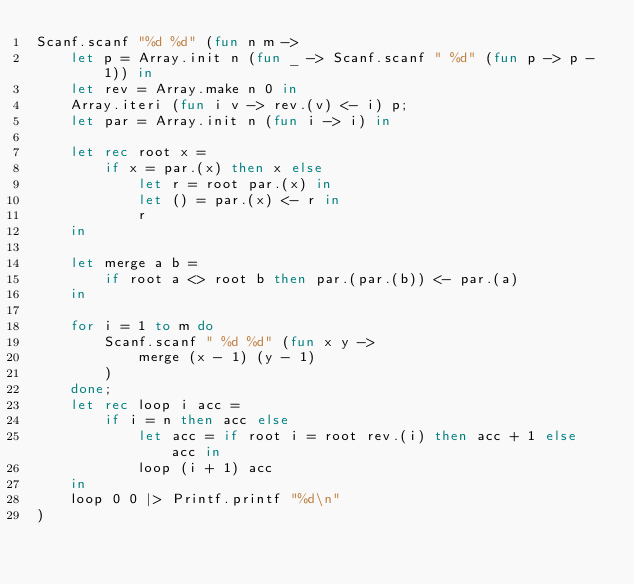Convert code to text. <code><loc_0><loc_0><loc_500><loc_500><_OCaml_>Scanf.scanf "%d %d" (fun n m ->
    let p = Array.init n (fun _ -> Scanf.scanf " %d" (fun p -> p - 1)) in
    let rev = Array.make n 0 in
    Array.iteri (fun i v -> rev.(v) <- i) p;
    let par = Array.init n (fun i -> i) in

    let rec root x =
        if x = par.(x) then x else
            let r = root par.(x) in
            let () = par.(x) <- r in
            r
    in

    let merge a b =
        if root a <> root b then par.(par.(b)) <- par.(a)
    in

    for i = 1 to m do
        Scanf.scanf " %d %d" (fun x y ->
            merge (x - 1) (y - 1)
        )
    done;
    let rec loop i acc =
        if i = n then acc else
            let acc = if root i = root rev.(i) then acc + 1 else acc in
            loop (i + 1) acc
    in
    loop 0 0 |> Printf.printf "%d\n"
)</code> 